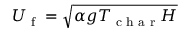Convert formula to latex. <formula><loc_0><loc_0><loc_500><loc_500>U _ { f } = \sqrt { \alpha g T _ { c h a r } H }</formula> 